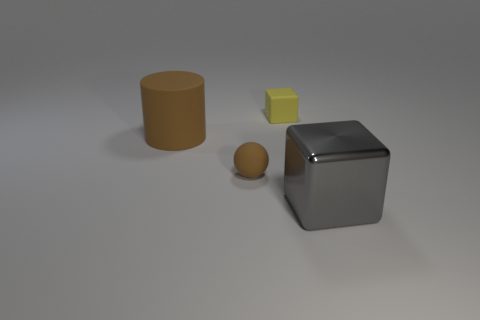Add 1 gray blocks. How many objects exist? 5 Subtract all spheres. How many objects are left? 3 Subtract 0 green cylinders. How many objects are left? 4 Subtract all big brown cylinders. Subtract all large green metallic balls. How many objects are left? 3 Add 2 matte balls. How many matte balls are left? 3 Add 1 brown balls. How many brown balls exist? 2 